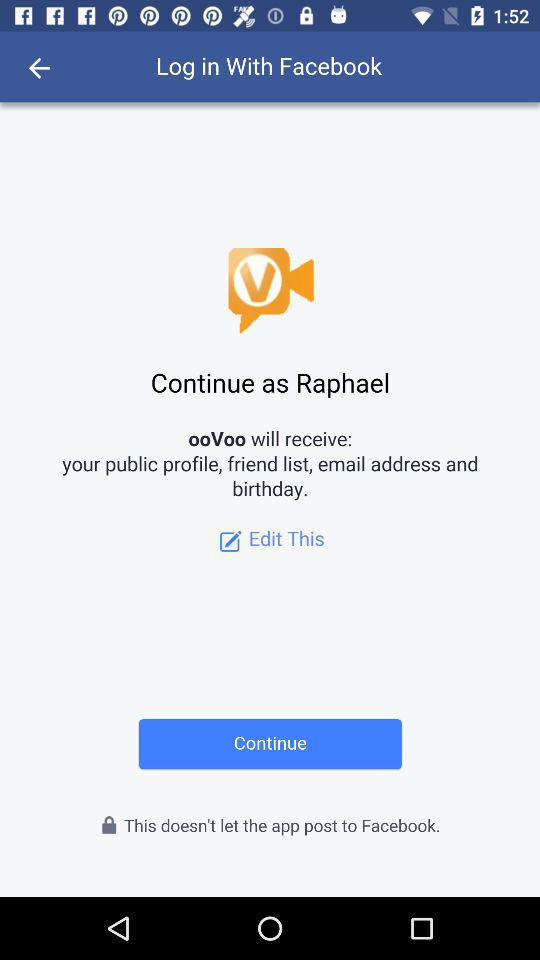What is the login name? The login name is Raphael. 